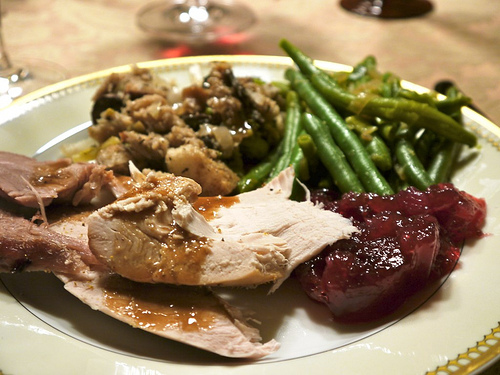<image>
Is the cranberry sauce to the right of the stuffing? Yes. From this viewpoint, the cranberry sauce is positioned to the right side relative to the stuffing. 